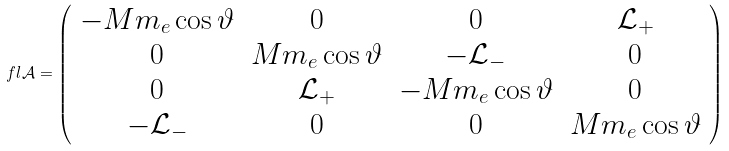Convert formula to latex. <formula><loc_0><loc_0><loc_500><loc_500>\ f l \mathcal { A } = \left ( \begin{array} { c c c c } - M m _ { e } \cos { \vartheta } & 0 & 0 & \mathcal { L } _ { + } \\ 0 & M m _ { e } \cos { \vartheta } & - \mathcal { L } _ { - } & 0 \\ 0 & \mathcal { L } _ { + } & - M m _ { e } \cos { \vartheta } & 0 \\ - \mathcal { L } _ { - } & 0 & 0 & M m _ { e } \cos { \vartheta } \end{array} \right )</formula> 